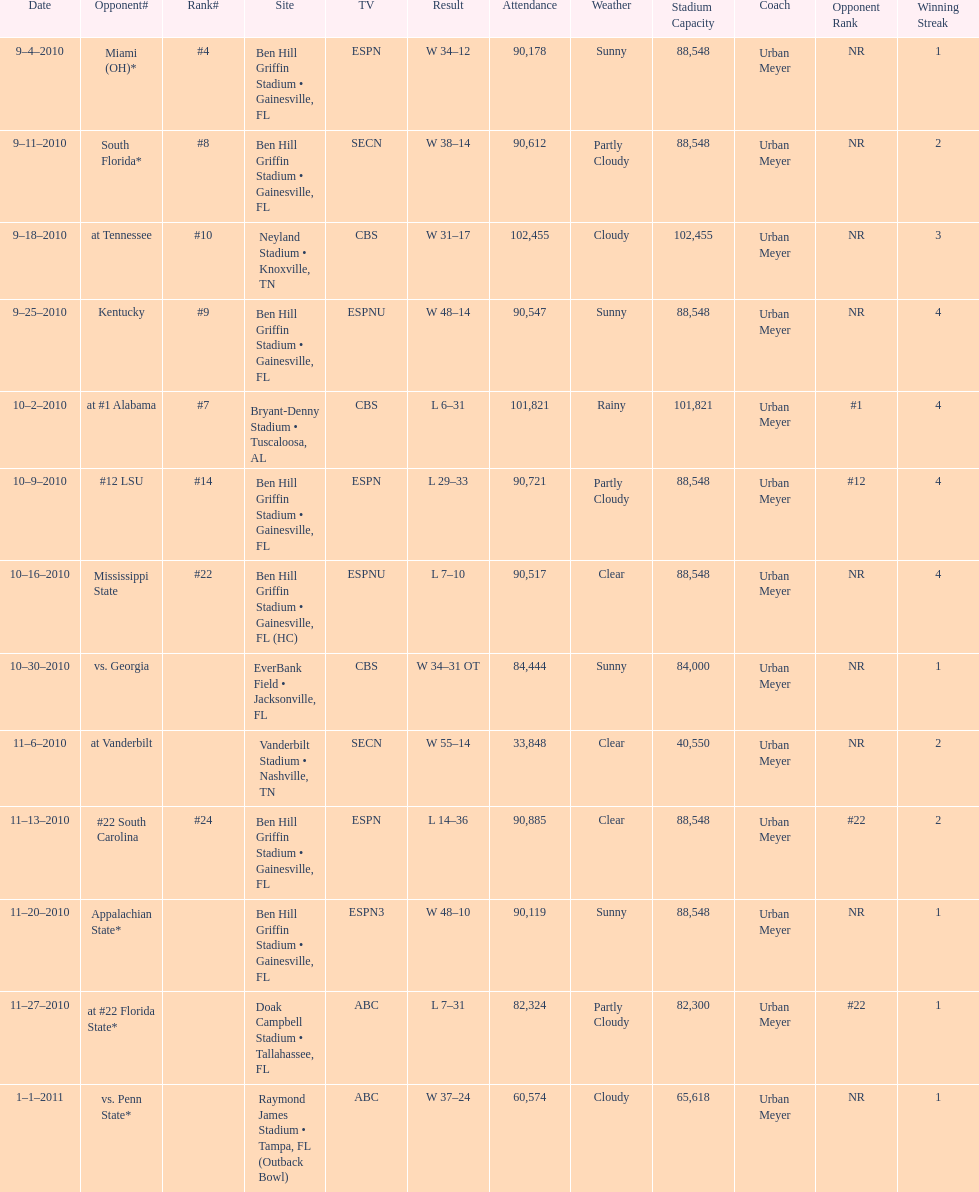The gators won the game on september 25, 2010. who won the previous game? Gators. 